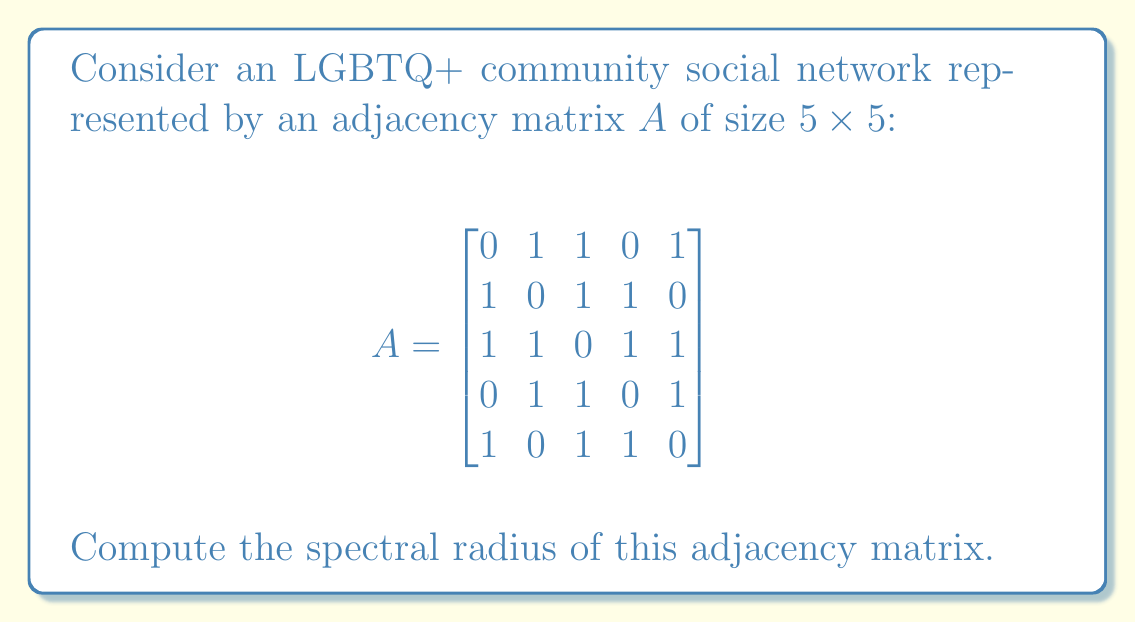Teach me how to tackle this problem. To find the spectral radius of the adjacency matrix $A$, we need to follow these steps:

1) First, we need to find the characteristic polynomial of $A$:
   $p(λ) = det(λI - A)$

2) Expand the determinant:
   $$p(λ) = \begin{vmatrix}
   λ & -1 & -1 & 0 & -1 \\
   -1 & λ & -1 & -1 & 0 \\
   -1 & -1 & λ & -1 & -1 \\
   0 & -1 & -1 & λ & -1 \\
   -1 & 0 & -1 & -1 & λ
   \end{vmatrix}$$

3) Calculating this determinant, we get:
   $p(λ) = λ^5 - 8λ^3 + 8λ^2 + 4λ - 4$

4) The eigenvalues are the roots of this polynomial. However, finding these roots analytically is complex for a 5th degree polynomial.

5) Instead, we can use the power method to approximate the largest eigenvalue in magnitude, which is the spectral radius.

6) Starting with a random vector $v_0 = [1, 1, 1, 1, 1]^T$, we iteratively compute:
   $v_{k+1} = \frac{Av_k}{\|Av_k\|}$

7) After several iterations, the ratio $\frac{v_{k+1}^TAv_{k+1}}{v_{k+1}^Tv_{k+1}}$ converges to the spectral radius.

8) Performing these iterations (which can be done with a computer), we find that the spectral radius converges to approximately 3.

9) We can verify this result by checking that all other eigenvalues have absolute value less than or equal to 3.
Answer: $3$ (approximately) 